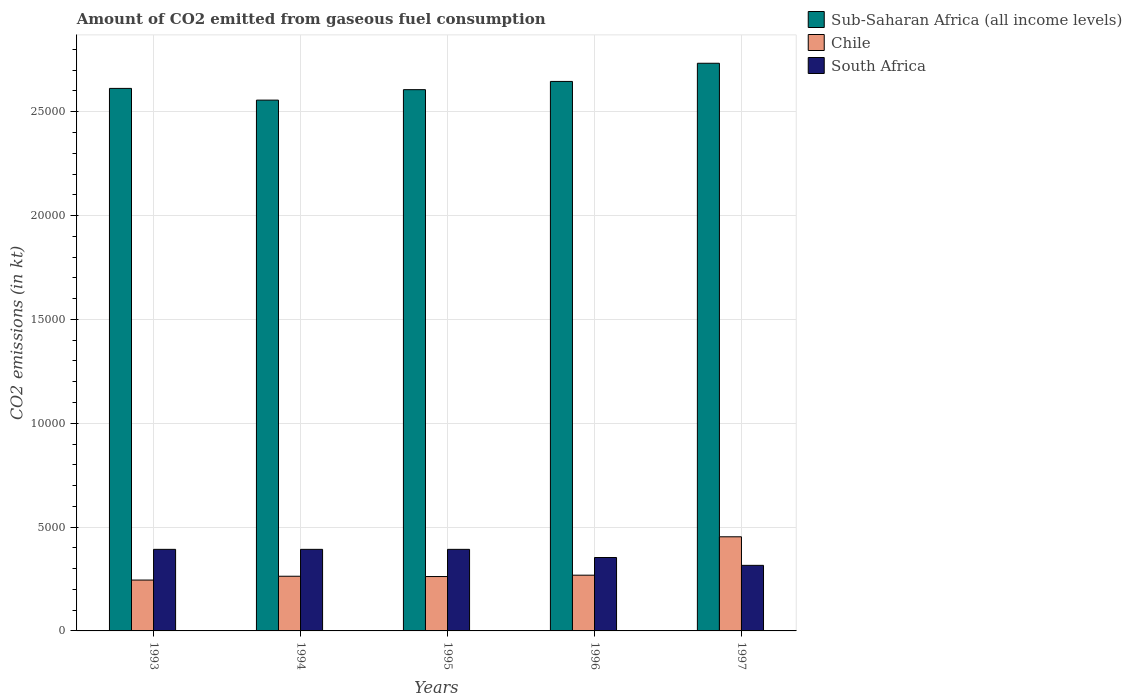How many different coloured bars are there?
Keep it short and to the point. 3. How many groups of bars are there?
Provide a succinct answer. 5. Are the number of bars per tick equal to the number of legend labels?
Your response must be concise. Yes. How many bars are there on the 3rd tick from the left?
Your answer should be compact. 3. How many bars are there on the 3rd tick from the right?
Give a very brief answer. 3. In how many cases, is the number of bars for a given year not equal to the number of legend labels?
Your response must be concise. 0. What is the amount of CO2 emitted in Chile in 1993?
Offer a terse response. 2449.56. Across all years, what is the maximum amount of CO2 emitted in Chile?
Keep it short and to the point. 4532.41. Across all years, what is the minimum amount of CO2 emitted in Chile?
Provide a short and direct response. 2449.56. In which year was the amount of CO2 emitted in South Africa minimum?
Your answer should be very brief. 1997. What is the total amount of CO2 emitted in Sub-Saharan Africa (all income levels) in the graph?
Provide a short and direct response. 1.32e+05. What is the difference between the amount of CO2 emitted in Sub-Saharan Africa (all income levels) in 1994 and that in 1995?
Make the answer very short. -503.65. What is the difference between the amount of CO2 emitted in South Africa in 1993 and the amount of CO2 emitted in Sub-Saharan Africa (all income levels) in 1996?
Your response must be concise. -2.25e+04. What is the average amount of CO2 emitted in Chile per year?
Provide a short and direct response. 2983.47. In the year 1996, what is the difference between the amount of CO2 emitted in South Africa and amount of CO2 emitted in Sub-Saharan Africa (all income levels)?
Ensure brevity in your answer.  -2.29e+04. Is the amount of CO2 emitted in Sub-Saharan Africa (all income levels) in 1995 less than that in 1996?
Offer a terse response. Yes. What is the difference between the highest and the second highest amount of CO2 emitted in Chile?
Your answer should be very brief. 1848.17. What is the difference between the highest and the lowest amount of CO2 emitted in Chile?
Provide a short and direct response. 2082.86. What does the 3rd bar from the right in 1993 represents?
Provide a short and direct response. Sub-Saharan Africa (all income levels). Is it the case that in every year, the sum of the amount of CO2 emitted in South Africa and amount of CO2 emitted in Sub-Saharan Africa (all income levels) is greater than the amount of CO2 emitted in Chile?
Offer a very short reply. Yes. How many bars are there?
Your response must be concise. 15. How many years are there in the graph?
Give a very brief answer. 5. Are the values on the major ticks of Y-axis written in scientific E-notation?
Offer a terse response. No. Does the graph contain any zero values?
Your answer should be very brief. No. Where does the legend appear in the graph?
Ensure brevity in your answer.  Top right. How many legend labels are there?
Provide a succinct answer. 3. What is the title of the graph?
Make the answer very short. Amount of CO2 emitted from gaseous fuel consumption. What is the label or title of the Y-axis?
Your answer should be very brief. CO2 emissions (in kt). What is the CO2 emissions (in kt) of Sub-Saharan Africa (all income levels) in 1993?
Offer a terse response. 2.61e+04. What is the CO2 emissions (in kt) in Chile in 1993?
Your answer should be compact. 2449.56. What is the CO2 emissions (in kt) of South Africa in 1993?
Your answer should be compact. 3927.36. What is the CO2 emissions (in kt) in Sub-Saharan Africa (all income levels) in 1994?
Make the answer very short. 2.56e+04. What is the CO2 emissions (in kt) in Chile in 1994?
Your answer should be very brief. 2632.91. What is the CO2 emissions (in kt) in South Africa in 1994?
Your answer should be compact. 3927.36. What is the CO2 emissions (in kt) of Sub-Saharan Africa (all income levels) in 1995?
Ensure brevity in your answer.  2.61e+04. What is the CO2 emissions (in kt) in Chile in 1995?
Provide a short and direct response. 2618.24. What is the CO2 emissions (in kt) in South Africa in 1995?
Give a very brief answer. 3927.36. What is the CO2 emissions (in kt) of Sub-Saharan Africa (all income levels) in 1996?
Your answer should be compact. 2.65e+04. What is the CO2 emissions (in kt) of Chile in 1996?
Provide a short and direct response. 2684.24. What is the CO2 emissions (in kt) of South Africa in 1996?
Your answer should be very brief. 3534.99. What is the CO2 emissions (in kt) of Sub-Saharan Africa (all income levels) in 1997?
Ensure brevity in your answer.  2.73e+04. What is the CO2 emissions (in kt) of Chile in 1997?
Your response must be concise. 4532.41. What is the CO2 emissions (in kt) of South Africa in 1997?
Provide a succinct answer. 3157.29. Across all years, what is the maximum CO2 emissions (in kt) in Sub-Saharan Africa (all income levels)?
Ensure brevity in your answer.  2.73e+04. Across all years, what is the maximum CO2 emissions (in kt) in Chile?
Give a very brief answer. 4532.41. Across all years, what is the maximum CO2 emissions (in kt) in South Africa?
Keep it short and to the point. 3927.36. Across all years, what is the minimum CO2 emissions (in kt) of Sub-Saharan Africa (all income levels)?
Give a very brief answer. 2.56e+04. Across all years, what is the minimum CO2 emissions (in kt) in Chile?
Offer a very short reply. 2449.56. Across all years, what is the minimum CO2 emissions (in kt) in South Africa?
Your response must be concise. 3157.29. What is the total CO2 emissions (in kt) of Sub-Saharan Africa (all income levels) in the graph?
Give a very brief answer. 1.32e+05. What is the total CO2 emissions (in kt) in Chile in the graph?
Make the answer very short. 1.49e+04. What is the total CO2 emissions (in kt) in South Africa in the graph?
Offer a terse response. 1.85e+04. What is the difference between the CO2 emissions (in kt) of Sub-Saharan Africa (all income levels) in 1993 and that in 1994?
Keep it short and to the point. 564.53. What is the difference between the CO2 emissions (in kt) in Chile in 1993 and that in 1994?
Ensure brevity in your answer.  -183.35. What is the difference between the CO2 emissions (in kt) in Sub-Saharan Africa (all income levels) in 1993 and that in 1995?
Your answer should be very brief. 60.88. What is the difference between the CO2 emissions (in kt) in Chile in 1993 and that in 1995?
Ensure brevity in your answer.  -168.68. What is the difference between the CO2 emissions (in kt) in Sub-Saharan Africa (all income levels) in 1993 and that in 1996?
Provide a short and direct response. -335.42. What is the difference between the CO2 emissions (in kt) in Chile in 1993 and that in 1996?
Offer a very short reply. -234.69. What is the difference between the CO2 emissions (in kt) of South Africa in 1993 and that in 1996?
Provide a short and direct response. 392.37. What is the difference between the CO2 emissions (in kt) of Sub-Saharan Africa (all income levels) in 1993 and that in 1997?
Ensure brevity in your answer.  -1210.59. What is the difference between the CO2 emissions (in kt) of Chile in 1993 and that in 1997?
Ensure brevity in your answer.  -2082.86. What is the difference between the CO2 emissions (in kt) in South Africa in 1993 and that in 1997?
Provide a short and direct response. 770.07. What is the difference between the CO2 emissions (in kt) of Sub-Saharan Africa (all income levels) in 1994 and that in 1995?
Ensure brevity in your answer.  -503.65. What is the difference between the CO2 emissions (in kt) of Chile in 1994 and that in 1995?
Give a very brief answer. 14.67. What is the difference between the CO2 emissions (in kt) in South Africa in 1994 and that in 1995?
Make the answer very short. 0. What is the difference between the CO2 emissions (in kt) of Sub-Saharan Africa (all income levels) in 1994 and that in 1996?
Offer a very short reply. -899.95. What is the difference between the CO2 emissions (in kt) of Chile in 1994 and that in 1996?
Provide a short and direct response. -51.34. What is the difference between the CO2 emissions (in kt) of South Africa in 1994 and that in 1996?
Make the answer very short. 392.37. What is the difference between the CO2 emissions (in kt) of Sub-Saharan Africa (all income levels) in 1994 and that in 1997?
Offer a very short reply. -1775.12. What is the difference between the CO2 emissions (in kt) of Chile in 1994 and that in 1997?
Your answer should be very brief. -1899.51. What is the difference between the CO2 emissions (in kt) of South Africa in 1994 and that in 1997?
Provide a short and direct response. 770.07. What is the difference between the CO2 emissions (in kt) of Sub-Saharan Africa (all income levels) in 1995 and that in 1996?
Offer a very short reply. -396.3. What is the difference between the CO2 emissions (in kt) of Chile in 1995 and that in 1996?
Make the answer very short. -66.01. What is the difference between the CO2 emissions (in kt) of South Africa in 1995 and that in 1996?
Give a very brief answer. 392.37. What is the difference between the CO2 emissions (in kt) in Sub-Saharan Africa (all income levels) in 1995 and that in 1997?
Provide a short and direct response. -1271.47. What is the difference between the CO2 emissions (in kt) in Chile in 1995 and that in 1997?
Your response must be concise. -1914.17. What is the difference between the CO2 emissions (in kt) in South Africa in 1995 and that in 1997?
Your response must be concise. 770.07. What is the difference between the CO2 emissions (in kt) of Sub-Saharan Africa (all income levels) in 1996 and that in 1997?
Your answer should be very brief. -875.17. What is the difference between the CO2 emissions (in kt) in Chile in 1996 and that in 1997?
Ensure brevity in your answer.  -1848.17. What is the difference between the CO2 emissions (in kt) of South Africa in 1996 and that in 1997?
Keep it short and to the point. 377.7. What is the difference between the CO2 emissions (in kt) in Sub-Saharan Africa (all income levels) in 1993 and the CO2 emissions (in kt) in Chile in 1994?
Your answer should be very brief. 2.35e+04. What is the difference between the CO2 emissions (in kt) of Sub-Saharan Africa (all income levels) in 1993 and the CO2 emissions (in kt) of South Africa in 1994?
Offer a very short reply. 2.22e+04. What is the difference between the CO2 emissions (in kt) in Chile in 1993 and the CO2 emissions (in kt) in South Africa in 1994?
Offer a terse response. -1477.8. What is the difference between the CO2 emissions (in kt) in Sub-Saharan Africa (all income levels) in 1993 and the CO2 emissions (in kt) in Chile in 1995?
Provide a short and direct response. 2.35e+04. What is the difference between the CO2 emissions (in kt) of Sub-Saharan Africa (all income levels) in 1993 and the CO2 emissions (in kt) of South Africa in 1995?
Make the answer very short. 2.22e+04. What is the difference between the CO2 emissions (in kt) of Chile in 1993 and the CO2 emissions (in kt) of South Africa in 1995?
Ensure brevity in your answer.  -1477.8. What is the difference between the CO2 emissions (in kt) in Sub-Saharan Africa (all income levels) in 1993 and the CO2 emissions (in kt) in Chile in 1996?
Offer a terse response. 2.34e+04. What is the difference between the CO2 emissions (in kt) of Sub-Saharan Africa (all income levels) in 1993 and the CO2 emissions (in kt) of South Africa in 1996?
Your answer should be very brief. 2.26e+04. What is the difference between the CO2 emissions (in kt) in Chile in 1993 and the CO2 emissions (in kt) in South Africa in 1996?
Ensure brevity in your answer.  -1085.43. What is the difference between the CO2 emissions (in kt) in Sub-Saharan Africa (all income levels) in 1993 and the CO2 emissions (in kt) in Chile in 1997?
Your answer should be compact. 2.16e+04. What is the difference between the CO2 emissions (in kt) in Sub-Saharan Africa (all income levels) in 1993 and the CO2 emissions (in kt) in South Africa in 1997?
Offer a terse response. 2.30e+04. What is the difference between the CO2 emissions (in kt) of Chile in 1993 and the CO2 emissions (in kt) of South Africa in 1997?
Provide a short and direct response. -707.73. What is the difference between the CO2 emissions (in kt) in Sub-Saharan Africa (all income levels) in 1994 and the CO2 emissions (in kt) in Chile in 1995?
Your answer should be compact. 2.29e+04. What is the difference between the CO2 emissions (in kt) in Sub-Saharan Africa (all income levels) in 1994 and the CO2 emissions (in kt) in South Africa in 1995?
Provide a succinct answer. 2.16e+04. What is the difference between the CO2 emissions (in kt) in Chile in 1994 and the CO2 emissions (in kt) in South Africa in 1995?
Your answer should be compact. -1294.45. What is the difference between the CO2 emissions (in kt) of Sub-Saharan Africa (all income levels) in 1994 and the CO2 emissions (in kt) of Chile in 1996?
Keep it short and to the point. 2.29e+04. What is the difference between the CO2 emissions (in kt) of Sub-Saharan Africa (all income levels) in 1994 and the CO2 emissions (in kt) of South Africa in 1996?
Your response must be concise. 2.20e+04. What is the difference between the CO2 emissions (in kt) of Chile in 1994 and the CO2 emissions (in kt) of South Africa in 1996?
Ensure brevity in your answer.  -902.08. What is the difference between the CO2 emissions (in kt) in Sub-Saharan Africa (all income levels) in 1994 and the CO2 emissions (in kt) in Chile in 1997?
Provide a short and direct response. 2.10e+04. What is the difference between the CO2 emissions (in kt) of Sub-Saharan Africa (all income levels) in 1994 and the CO2 emissions (in kt) of South Africa in 1997?
Your answer should be compact. 2.24e+04. What is the difference between the CO2 emissions (in kt) in Chile in 1994 and the CO2 emissions (in kt) in South Africa in 1997?
Provide a short and direct response. -524.38. What is the difference between the CO2 emissions (in kt) of Sub-Saharan Africa (all income levels) in 1995 and the CO2 emissions (in kt) of Chile in 1996?
Your answer should be very brief. 2.34e+04. What is the difference between the CO2 emissions (in kt) of Sub-Saharan Africa (all income levels) in 1995 and the CO2 emissions (in kt) of South Africa in 1996?
Ensure brevity in your answer.  2.25e+04. What is the difference between the CO2 emissions (in kt) of Chile in 1995 and the CO2 emissions (in kt) of South Africa in 1996?
Offer a terse response. -916.75. What is the difference between the CO2 emissions (in kt) of Sub-Saharan Africa (all income levels) in 1995 and the CO2 emissions (in kt) of Chile in 1997?
Your answer should be compact. 2.15e+04. What is the difference between the CO2 emissions (in kt) of Sub-Saharan Africa (all income levels) in 1995 and the CO2 emissions (in kt) of South Africa in 1997?
Give a very brief answer. 2.29e+04. What is the difference between the CO2 emissions (in kt) of Chile in 1995 and the CO2 emissions (in kt) of South Africa in 1997?
Provide a short and direct response. -539.05. What is the difference between the CO2 emissions (in kt) of Sub-Saharan Africa (all income levels) in 1996 and the CO2 emissions (in kt) of Chile in 1997?
Offer a very short reply. 2.19e+04. What is the difference between the CO2 emissions (in kt) of Sub-Saharan Africa (all income levels) in 1996 and the CO2 emissions (in kt) of South Africa in 1997?
Offer a very short reply. 2.33e+04. What is the difference between the CO2 emissions (in kt) of Chile in 1996 and the CO2 emissions (in kt) of South Africa in 1997?
Make the answer very short. -473.04. What is the average CO2 emissions (in kt) of Sub-Saharan Africa (all income levels) per year?
Give a very brief answer. 2.63e+04. What is the average CO2 emissions (in kt) of Chile per year?
Your answer should be very brief. 2983.47. What is the average CO2 emissions (in kt) of South Africa per year?
Make the answer very short. 3694.87. In the year 1993, what is the difference between the CO2 emissions (in kt) in Sub-Saharan Africa (all income levels) and CO2 emissions (in kt) in Chile?
Your answer should be very brief. 2.37e+04. In the year 1993, what is the difference between the CO2 emissions (in kt) of Sub-Saharan Africa (all income levels) and CO2 emissions (in kt) of South Africa?
Ensure brevity in your answer.  2.22e+04. In the year 1993, what is the difference between the CO2 emissions (in kt) in Chile and CO2 emissions (in kt) in South Africa?
Provide a short and direct response. -1477.8. In the year 1994, what is the difference between the CO2 emissions (in kt) of Sub-Saharan Africa (all income levels) and CO2 emissions (in kt) of Chile?
Your answer should be very brief. 2.29e+04. In the year 1994, what is the difference between the CO2 emissions (in kt) in Sub-Saharan Africa (all income levels) and CO2 emissions (in kt) in South Africa?
Give a very brief answer. 2.16e+04. In the year 1994, what is the difference between the CO2 emissions (in kt) in Chile and CO2 emissions (in kt) in South Africa?
Your response must be concise. -1294.45. In the year 1995, what is the difference between the CO2 emissions (in kt) of Sub-Saharan Africa (all income levels) and CO2 emissions (in kt) of Chile?
Your response must be concise. 2.34e+04. In the year 1995, what is the difference between the CO2 emissions (in kt) in Sub-Saharan Africa (all income levels) and CO2 emissions (in kt) in South Africa?
Give a very brief answer. 2.21e+04. In the year 1995, what is the difference between the CO2 emissions (in kt) of Chile and CO2 emissions (in kt) of South Africa?
Provide a short and direct response. -1309.12. In the year 1996, what is the difference between the CO2 emissions (in kt) of Sub-Saharan Africa (all income levels) and CO2 emissions (in kt) of Chile?
Keep it short and to the point. 2.38e+04. In the year 1996, what is the difference between the CO2 emissions (in kt) of Sub-Saharan Africa (all income levels) and CO2 emissions (in kt) of South Africa?
Provide a short and direct response. 2.29e+04. In the year 1996, what is the difference between the CO2 emissions (in kt) in Chile and CO2 emissions (in kt) in South Africa?
Make the answer very short. -850.74. In the year 1997, what is the difference between the CO2 emissions (in kt) of Sub-Saharan Africa (all income levels) and CO2 emissions (in kt) of Chile?
Your answer should be compact. 2.28e+04. In the year 1997, what is the difference between the CO2 emissions (in kt) of Sub-Saharan Africa (all income levels) and CO2 emissions (in kt) of South Africa?
Provide a succinct answer. 2.42e+04. In the year 1997, what is the difference between the CO2 emissions (in kt) of Chile and CO2 emissions (in kt) of South Africa?
Your answer should be compact. 1375.12. What is the ratio of the CO2 emissions (in kt) of Sub-Saharan Africa (all income levels) in 1993 to that in 1994?
Your answer should be compact. 1.02. What is the ratio of the CO2 emissions (in kt) in Chile in 1993 to that in 1994?
Keep it short and to the point. 0.93. What is the ratio of the CO2 emissions (in kt) of Sub-Saharan Africa (all income levels) in 1993 to that in 1995?
Offer a terse response. 1. What is the ratio of the CO2 emissions (in kt) of Chile in 1993 to that in 1995?
Make the answer very short. 0.94. What is the ratio of the CO2 emissions (in kt) of South Africa in 1993 to that in 1995?
Ensure brevity in your answer.  1. What is the ratio of the CO2 emissions (in kt) of Sub-Saharan Africa (all income levels) in 1993 to that in 1996?
Keep it short and to the point. 0.99. What is the ratio of the CO2 emissions (in kt) of Chile in 1993 to that in 1996?
Your answer should be compact. 0.91. What is the ratio of the CO2 emissions (in kt) of South Africa in 1993 to that in 1996?
Make the answer very short. 1.11. What is the ratio of the CO2 emissions (in kt) in Sub-Saharan Africa (all income levels) in 1993 to that in 1997?
Make the answer very short. 0.96. What is the ratio of the CO2 emissions (in kt) in Chile in 1993 to that in 1997?
Provide a short and direct response. 0.54. What is the ratio of the CO2 emissions (in kt) in South Africa in 1993 to that in 1997?
Your answer should be very brief. 1.24. What is the ratio of the CO2 emissions (in kt) of Sub-Saharan Africa (all income levels) in 1994 to that in 1995?
Offer a terse response. 0.98. What is the ratio of the CO2 emissions (in kt) in Chile in 1994 to that in 1995?
Your response must be concise. 1.01. What is the ratio of the CO2 emissions (in kt) in South Africa in 1994 to that in 1995?
Ensure brevity in your answer.  1. What is the ratio of the CO2 emissions (in kt) in Chile in 1994 to that in 1996?
Your answer should be compact. 0.98. What is the ratio of the CO2 emissions (in kt) of South Africa in 1994 to that in 1996?
Provide a short and direct response. 1.11. What is the ratio of the CO2 emissions (in kt) in Sub-Saharan Africa (all income levels) in 1994 to that in 1997?
Your response must be concise. 0.94. What is the ratio of the CO2 emissions (in kt) in Chile in 1994 to that in 1997?
Ensure brevity in your answer.  0.58. What is the ratio of the CO2 emissions (in kt) in South Africa in 1994 to that in 1997?
Provide a short and direct response. 1.24. What is the ratio of the CO2 emissions (in kt) of Sub-Saharan Africa (all income levels) in 1995 to that in 1996?
Give a very brief answer. 0.98. What is the ratio of the CO2 emissions (in kt) in Chile in 1995 to that in 1996?
Provide a succinct answer. 0.98. What is the ratio of the CO2 emissions (in kt) of South Africa in 1995 to that in 1996?
Your answer should be compact. 1.11. What is the ratio of the CO2 emissions (in kt) of Sub-Saharan Africa (all income levels) in 1995 to that in 1997?
Offer a terse response. 0.95. What is the ratio of the CO2 emissions (in kt) in Chile in 1995 to that in 1997?
Provide a short and direct response. 0.58. What is the ratio of the CO2 emissions (in kt) in South Africa in 1995 to that in 1997?
Make the answer very short. 1.24. What is the ratio of the CO2 emissions (in kt) in Chile in 1996 to that in 1997?
Make the answer very short. 0.59. What is the ratio of the CO2 emissions (in kt) of South Africa in 1996 to that in 1997?
Your response must be concise. 1.12. What is the difference between the highest and the second highest CO2 emissions (in kt) in Sub-Saharan Africa (all income levels)?
Provide a succinct answer. 875.17. What is the difference between the highest and the second highest CO2 emissions (in kt) of Chile?
Provide a short and direct response. 1848.17. What is the difference between the highest and the lowest CO2 emissions (in kt) in Sub-Saharan Africa (all income levels)?
Your answer should be compact. 1775.12. What is the difference between the highest and the lowest CO2 emissions (in kt) in Chile?
Your answer should be very brief. 2082.86. What is the difference between the highest and the lowest CO2 emissions (in kt) in South Africa?
Offer a terse response. 770.07. 